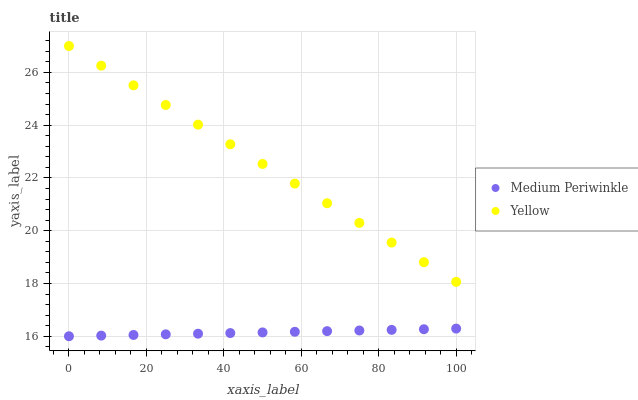Does Medium Periwinkle have the minimum area under the curve?
Answer yes or no. Yes. Does Yellow have the maximum area under the curve?
Answer yes or no. Yes. Does Yellow have the minimum area under the curve?
Answer yes or no. No. Is Medium Periwinkle the smoothest?
Answer yes or no. Yes. Is Yellow the roughest?
Answer yes or no. Yes. Is Yellow the smoothest?
Answer yes or no. No. Does Medium Periwinkle have the lowest value?
Answer yes or no. Yes. Does Yellow have the lowest value?
Answer yes or no. No. Does Yellow have the highest value?
Answer yes or no. Yes. Is Medium Periwinkle less than Yellow?
Answer yes or no. Yes. Is Yellow greater than Medium Periwinkle?
Answer yes or no. Yes. Does Medium Periwinkle intersect Yellow?
Answer yes or no. No. 